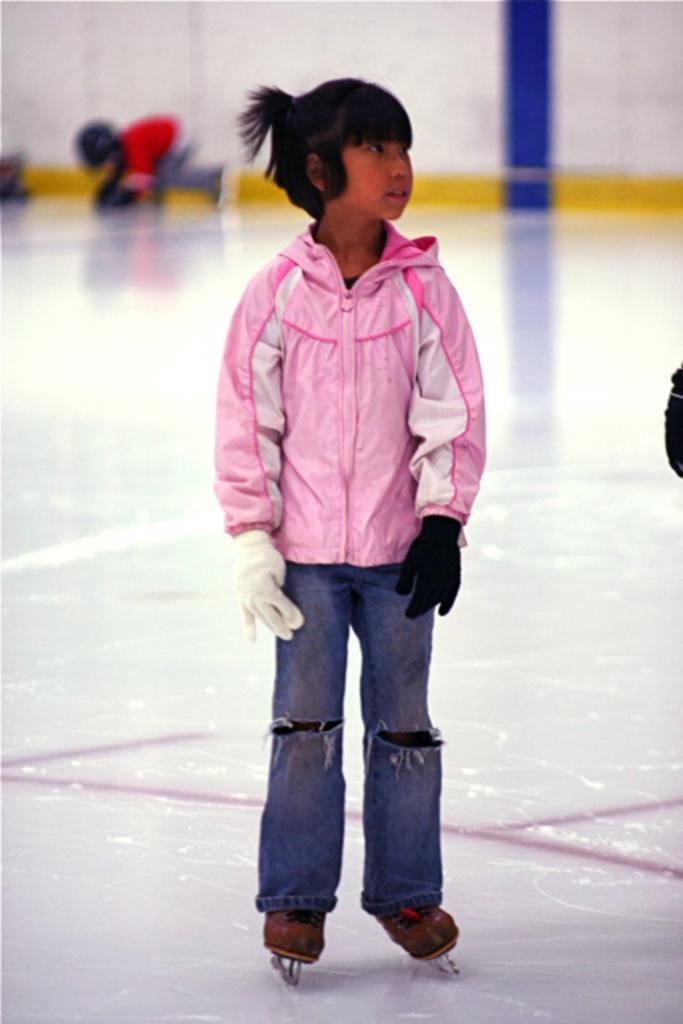Describe this image in one or two sentences. In this picture I can observe a girl in the middle of the picture. She is wearing ice skating shoes. She is standing on the ice skating rink. 